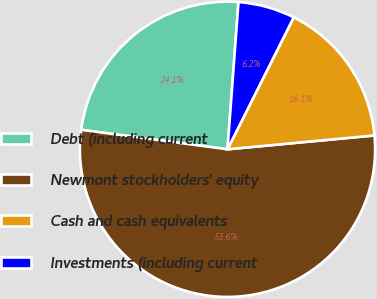Convert chart to OTSL. <chart><loc_0><loc_0><loc_500><loc_500><pie_chart><fcel>Debt (including current<fcel>Newmont stockholders' equity<fcel>Cash and cash equivalents<fcel>Investments (including current<nl><fcel>24.08%<fcel>53.6%<fcel>16.1%<fcel>6.22%<nl></chart> 